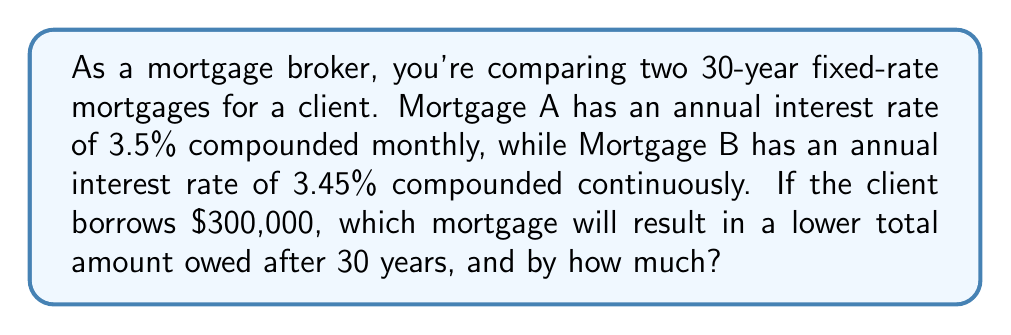Teach me how to tackle this problem. Let's approach this step-by-step:

1) For Mortgage A (compounded monthly):
   The formula for compound interest is:
   $$ A = P(1 + \frac{r}{n})^{nt} $$
   where A is the final amount, P is the principal, r is the annual interest rate, n is the number of times interest is compounded per year, and t is the time in years.

   $$ A_A = 300000(1 + \frac{0.035}{12})^{12 \cdot 30} $$
   $$ A_A = 300000(1.002917)^{360} $$
   $$ A_A = 300000 \cdot 2.807624 $$
   $$ A_A = 842,287.20 $$

2) For Mortgage B (compounded continuously):
   The formula for continuous compound interest is:
   $$ A = Pe^{rt} $$
   where e is Euler's number (approximately 2.71828).

   $$ A_B = 300000e^{0.0345 \cdot 30} $$
   $$ A_B = 300000 \cdot 2.813692 $$
   $$ A_B = 844,107.60 $$

3) Difference:
   $$ 844,107.60 - 842,287.20 = 1,820.40 $$

Therefore, Mortgage A results in a lower total amount owed after 30 years, by $1,820.40.
Answer: Mortgage A; $1,820.40 less 